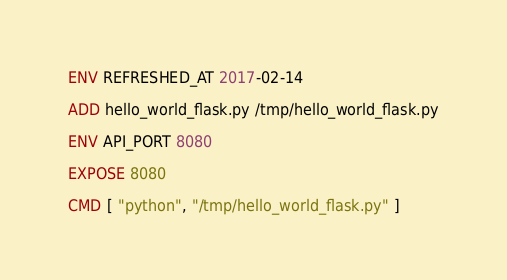Convert code to text. <code><loc_0><loc_0><loc_500><loc_500><_Dockerfile_>
ENV REFRESHED_AT 2017-02-14

ADD hello_world_flask.py /tmp/hello_world_flask.py

ENV API_PORT 8080

EXPOSE 8080

CMD [ "python", "/tmp/hello_world_flask.py" ]
</code> 